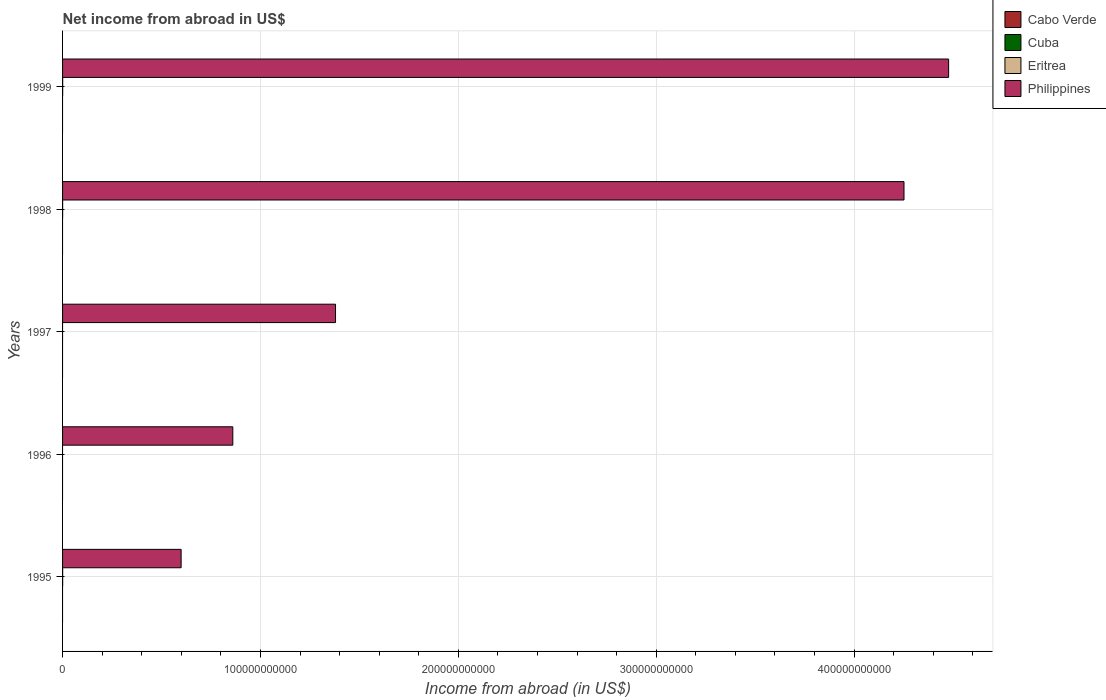Are the number of bars per tick equal to the number of legend labels?
Your answer should be very brief. No. How many bars are there on the 4th tick from the top?
Keep it short and to the point. 1. In how many cases, is the number of bars for a given year not equal to the number of legend labels?
Make the answer very short. 5. What is the net income from abroad in Cabo Verde in 1995?
Your answer should be very brief. 0. Across all years, what is the maximum net income from abroad in Philippines?
Ensure brevity in your answer.  4.48e+11. What is the total net income from abroad in Cuba in the graph?
Provide a succinct answer. 0. What is the difference between the net income from abroad in Philippines in 1995 and that in 1998?
Provide a succinct answer. -3.65e+11. What is the difference between the net income from abroad in Cabo Verde in 1997 and the net income from abroad in Eritrea in 1998?
Your answer should be very brief. -3.17e+07. What is the average net income from abroad in Philippines per year?
Your answer should be very brief. 2.31e+11. In the year 1998, what is the difference between the net income from abroad in Philippines and net income from abroad in Eritrea?
Keep it short and to the point. 4.25e+11. Is the net income from abroad in Philippines in 1995 less than that in 1998?
Ensure brevity in your answer.  Yes. What is the difference between the highest and the second highest net income from abroad in Eritrea?
Provide a short and direct response. 1.40e+06. What is the difference between the highest and the lowest net income from abroad in Eritrea?
Your response must be concise. 4.97e+07. Is the sum of the net income from abroad in Philippines in 1997 and 1998 greater than the maximum net income from abroad in Eritrea across all years?
Provide a succinct answer. Yes. Is it the case that in every year, the sum of the net income from abroad in Cabo Verde and net income from abroad in Cuba is greater than the sum of net income from abroad in Eritrea and net income from abroad in Philippines?
Make the answer very short. No. What is the difference between two consecutive major ticks on the X-axis?
Provide a short and direct response. 1.00e+11. Where does the legend appear in the graph?
Ensure brevity in your answer.  Top right. How are the legend labels stacked?
Your answer should be very brief. Vertical. What is the title of the graph?
Provide a succinct answer. Net income from abroad in US$. What is the label or title of the X-axis?
Your response must be concise. Income from abroad (in US$). What is the label or title of the Y-axis?
Your response must be concise. Years. What is the Income from abroad (in US$) of Eritrea in 1995?
Give a very brief answer. 4.83e+07. What is the Income from abroad (in US$) of Philippines in 1995?
Provide a succinct answer. 5.99e+1. What is the Income from abroad (in US$) of Cabo Verde in 1996?
Your answer should be very brief. 0. What is the Income from abroad (in US$) in Cuba in 1996?
Offer a terse response. 0. What is the Income from abroad (in US$) in Eritrea in 1996?
Make the answer very short. 0. What is the Income from abroad (in US$) of Philippines in 1996?
Keep it short and to the point. 8.60e+1. What is the Income from abroad (in US$) in Cabo Verde in 1997?
Ensure brevity in your answer.  0. What is the Income from abroad (in US$) in Philippines in 1997?
Offer a very short reply. 1.38e+11. What is the Income from abroad (in US$) in Eritrea in 1998?
Ensure brevity in your answer.  3.17e+07. What is the Income from abroad (in US$) in Philippines in 1998?
Make the answer very short. 4.25e+11. What is the Income from abroad (in US$) of Cuba in 1999?
Give a very brief answer. 0. What is the Income from abroad (in US$) of Eritrea in 1999?
Your response must be concise. 4.97e+07. What is the Income from abroad (in US$) of Philippines in 1999?
Make the answer very short. 4.48e+11. Across all years, what is the maximum Income from abroad (in US$) of Eritrea?
Keep it short and to the point. 4.97e+07. Across all years, what is the maximum Income from abroad (in US$) of Philippines?
Keep it short and to the point. 4.48e+11. Across all years, what is the minimum Income from abroad (in US$) in Philippines?
Provide a succinct answer. 5.99e+1. What is the total Income from abroad (in US$) in Eritrea in the graph?
Provide a short and direct response. 1.30e+08. What is the total Income from abroad (in US$) in Philippines in the graph?
Your response must be concise. 1.16e+12. What is the difference between the Income from abroad (in US$) in Philippines in 1995 and that in 1996?
Your answer should be compact. -2.61e+1. What is the difference between the Income from abroad (in US$) of Philippines in 1995 and that in 1997?
Keep it short and to the point. -7.80e+1. What is the difference between the Income from abroad (in US$) in Eritrea in 1995 and that in 1998?
Ensure brevity in your answer.  1.66e+07. What is the difference between the Income from abroad (in US$) in Philippines in 1995 and that in 1998?
Ensure brevity in your answer.  -3.65e+11. What is the difference between the Income from abroad (in US$) of Eritrea in 1995 and that in 1999?
Provide a short and direct response. -1.40e+06. What is the difference between the Income from abroad (in US$) in Philippines in 1995 and that in 1999?
Give a very brief answer. -3.88e+11. What is the difference between the Income from abroad (in US$) of Philippines in 1996 and that in 1997?
Your answer should be compact. -5.19e+1. What is the difference between the Income from abroad (in US$) in Philippines in 1996 and that in 1998?
Your answer should be very brief. -3.39e+11. What is the difference between the Income from abroad (in US$) in Philippines in 1996 and that in 1999?
Ensure brevity in your answer.  -3.62e+11. What is the difference between the Income from abroad (in US$) in Philippines in 1997 and that in 1998?
Provide a succinct answer. -2.87e+11. What is the difference between the Income from abroad (in US$) of Philippines in 1997 and that in 1999?
Keep it short and to the point. -3.10e+11. What is the difference between the Income from abroad (in US$) in Eritrea in 1998 and that in 1999?
Make the answer very short. -1.80e+07. What is the difference between the Income from abroad (in US$) in Philippines in 1998 and that in 1999?
Offer a very short reply. -2.26e+1. What is the difference between the Income from abroad (in US$) of Eritrea in 1995 and the Income from abroad (in US$) of Philippines in 1996?
Make the answer very short. -8.60e+1. What is the difference between the Income from abroad (in US$) of Eritrea in 1995 and the Income from abroad (in US$) of Philippines in 1997?
Provide a succinct answer. -1.38e+11. What is the difference between the Income from abroad (in US$) in Eritrea in 1995 and the Income from abroad (in US$) in Philippines in 1998?
Make the answer very short. -4.25e+11. What is the difference between the Income from abroad (in US$) in Eritrea in 1995 and the Income from abroad (in US$) in Philippines in 1999?
Offer a terse response. -4.48e+11. What is the difference between the Income from abroad (in US$) of Eritrea in 1998 and the Income from abroad (in US$) of Philippines in 1999?
Ensure brevity in your answer.  -4.48e+11. What is the average Income from abroad (in US$) of Eritrea per year?
Provide a short and direct response. 2.59e+07. What is the average Income from abroad (in US$) in Philippines per year?
Provide a succinct answer. 2.31e+11. In the year 1995, what is the difference between the Income from abroad (in US$) of Eritrea and Income from abroad (in US$) of Philippines?
Make the answer very short. -5.99e+1. In the year 1998, what is the difference between the Income from abroad (in US$) in Eritrea and Income from abroad (in US$) in Philippines?
Your answer should be very brief. -4.25e+11. In the year 1999, what is the difference between the Income from abroad (in US$) of Eritrea and Income from abroad (in US$) of Philippines?
Provide a short and direct response. -4.48e+11. What is the ratio of the Income from abroad (in US$) in Philippines in 1995 to that in 1996?
Provide a short and direct response. 0.7. What is the ratio of the Income from abroad (in US$) in Philippines in 1995 to that in 1997?
Offer a very short reply. 0.43. What is the ratio of the Income from abroad (in US$) of Eritrea in 1995 to that in 1998?
Give a very brief answer. 1.52. What is the ratio of the Income from abroad (in US$) in Philippines in 1995 to that in 1998?
Your answer should be very brief. 0.14. What is the ratio of the Income from abroad (in US$) of Eritrea in 1995 to that in 1999?
Provide a short and direct response. 0.97. What is the ratio of the Income from abroad (in US$) in Philippines in 1995 to that in 1999?
Your answer should be very brief. 0.13. What is the ratio of the Income from abroad (in US$) of Philippines in 1996 to that in 1997?
Ensure brevity in your answer.  0.62. What is the ratio of the Income from abroad (in US$) in Philippines in 1996 to that in 1998?
Keep it short and to the point. 0.2. What is the ratio of the Income from abroad (in US$) in Philippines in 1996 to that in 1999?
Keep it short and to the point. 0.19. What is the ratio of the Income from abroad (in US$) of Philippines in 1997 to that in 1998?
Make the answer very short. 0.32. What is the ratio of the Income from abroad (in US$) in Philippines in 1997 to that in 1999?
Offer a very short reply. 0.31. What is the ratio of the Income from abroad (in US$) of Eritrea in 1998 to that in 1999?
Ensure brevity in your answer.  0.64. What is the ratio of the Income from abroad (in US$) of Philippines in 1998 to that in 1999?
Offer a terse response. 0.95. What is the difference between the highest and the second highest Income from abroad (in US$) in Eritrea?
Your response must be concise. 1.40e+06. What is the difference between the highest and the second highest Income from abroad (in US$) in Philippines?
Your response must be concise. 2.26e+1. What is the difference between the highest and the lowest Income from abroad (in US$) in Eritrea?
Make the answer very short. 4.97e+07. What is the difference between the highest and the lowest Income from abroad (in US$) of Philippines?
Provide a succinct answer. 3.88e+11. 